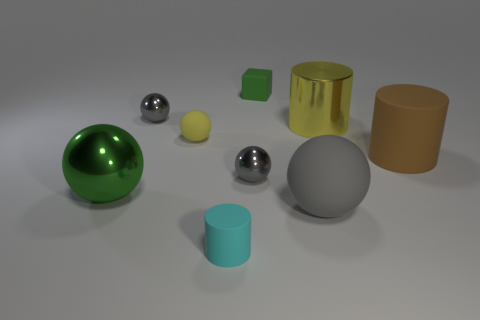Subtract all yellow blocks. How many gray spheres are left? 3 Subtract all green balls. How many balls are left? 4 Subtract 1 cylinders. How many cylinders are left? 2 Subtract all yellow rubber balls. How many balls are left? 4 Subtract all brown balls. Subtract all blue cubes. How many balls are left? 5 Subtract all spheres. How many objects are left? 4 Add 2 rubber things. How many rubber things exist? 7 Subtract 1 brown cylinders. How many objects are left? 8 Subtract all tiny green rubber balls. Subtract all green balls. How many objects are left? 8 Add 4 rubber blocks. How many rubber blocks are left? 5 